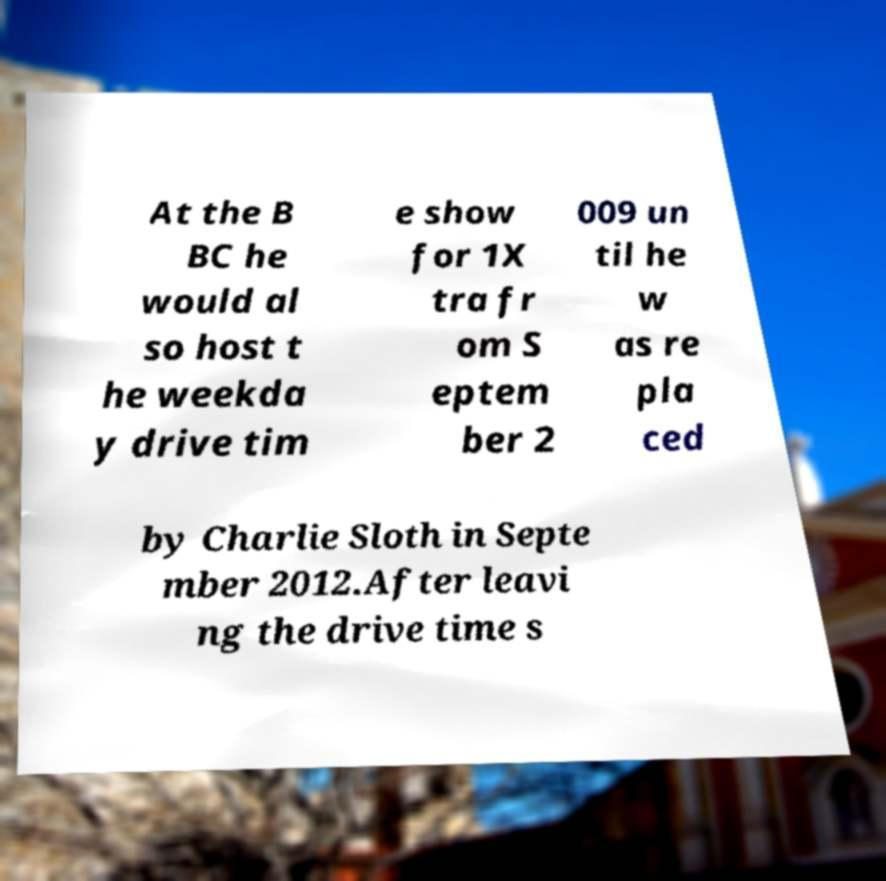Could you extract and type out the text from this image? At the B BC he would al so host t he weekda y drive tim e show for 1X tra fr om S eptem ber 2 009 un til he w as re pla ced by Charlie Sloth in Septe mber 2012.After leavi ng the drive time s 